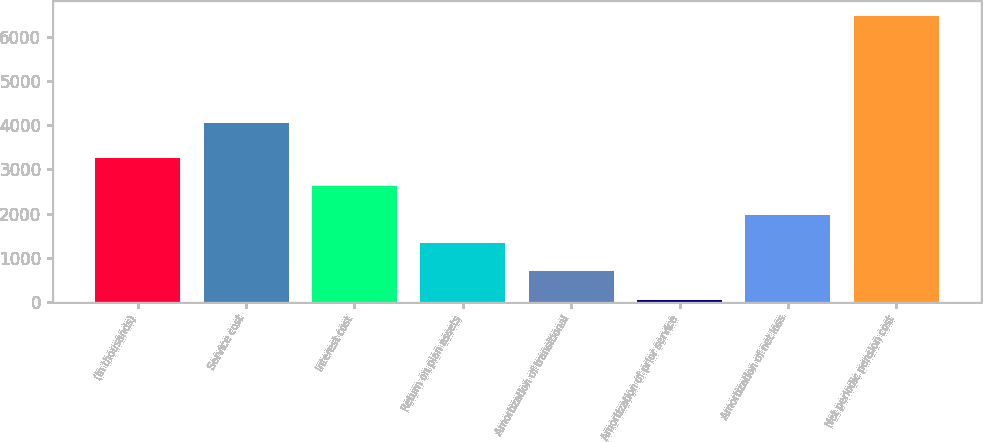Convert chart to OTSL. <chart><loc_0><loc_0><loc_500><loc_500><bar_chart><fcel>(In thousands)<fcel>Service cost<fcel>Interest cost<fcel>Return on plan assets<fcel>Amortization of transitional<fcel>Amortization of prior service<fcel>Amortization of net loss<fcel>Net periodic pension cost<nl><fcel>3260.5<fcel>4054<fcel>2618.8<fcel>1335.4<fcel>693.7<fcel>52<fcel>1977.1<fcel>6469<nl></chart> 